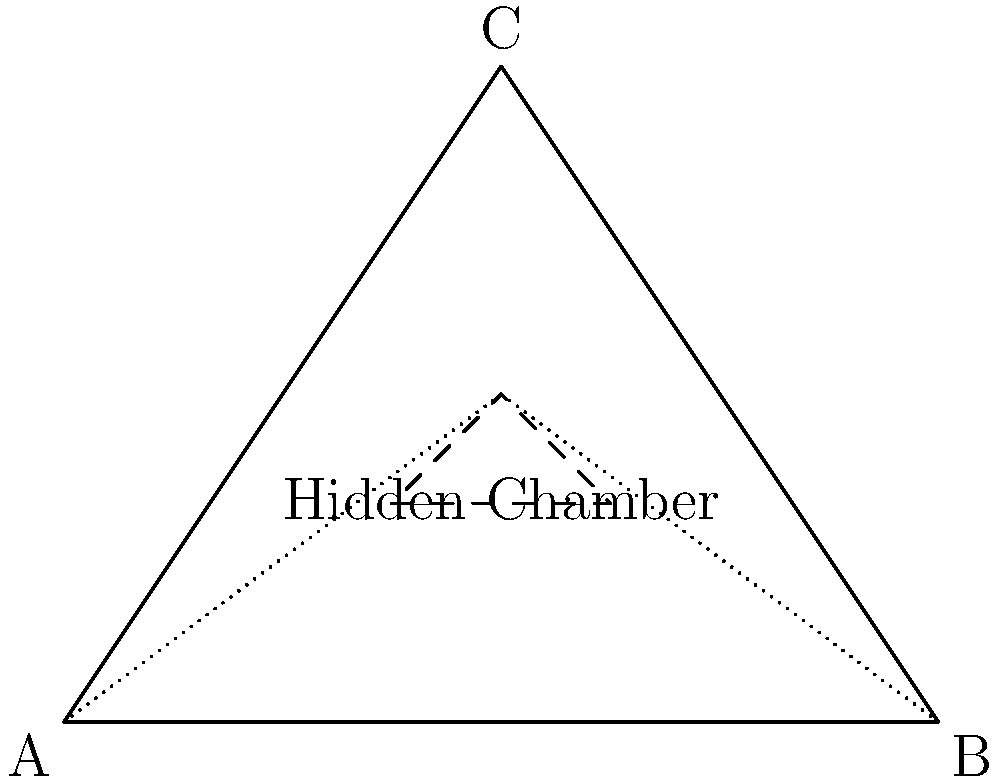In a pyramid-shaped building with a hidden chamber, as shown in the diagram, what structural consideration is most critical to maintain the integrity of the structure while concealing the chamber's existence? To answer this question, we need to consider several factors:

1. Load distribution: The pyramid shape naturally distributes loads from the apex to the base. The hidden chamber disrupts this natural load path.

2. Structural support: The dotted lines in the diagram represent potential load-bearing elements that would typically exist in a solid pyramid.

3. Chamber location: The hidden chamber is positioned off-center and closer to one side of the pyramid.

4. Concealment: The structure must appear normal from the outside to hide the chamber's existence.

5. Material strength: The materials used must be strong enough to support the altered load distribution.

Given these considerations:

1. The most critical factor is maintaining the load path from the apex to the base while working around the hidden chamber.

2. This requires careful design of structural supports that can redirect loads around the chamber without being detectable from the outside.

3. The asymmetrical position of the chamber adds complexity, as it creates uneven load distribution.

4. To maintain concealment, any additional supports or reinforcements must be incorporated within the existing structure.

5. The materials used for the areas surrounding the chamber must be stronger than what would typically be required for a solid pyramid to compensate for the void space.

Therefore, the most critical structural consideration is the design of hidden load-bearing elements that can support the pyramid's weight while accommodating the chamber and maintaining the appearance of a solid structure.
Answer: Hidden load-bearing elements 